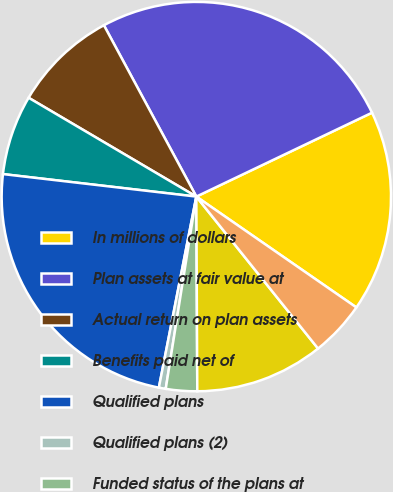Convert chart to OTSL. <chart><loc_0><loc_0><loc_500><loc_500><pie_chart><fcel>In millions of dollars<fcel>Plan assets at fair value at<fcel>Actual return on plan assets<fcel>Benefits paid net of<fcel>Qualified plans<fcel>Qualified plans (2)<fcel>Funded status of the plans at<fcel>Benefit liability<fcel>Net amount recognized on the<nl><fcel>16.73%<fcel>25.78%<fcel>8.65%<fcel>6.63%<fcel>23.76%<fcel>0.57%<fcel>2.59%<fcel>10.67%<fcel>4.61%<nl></chart> 